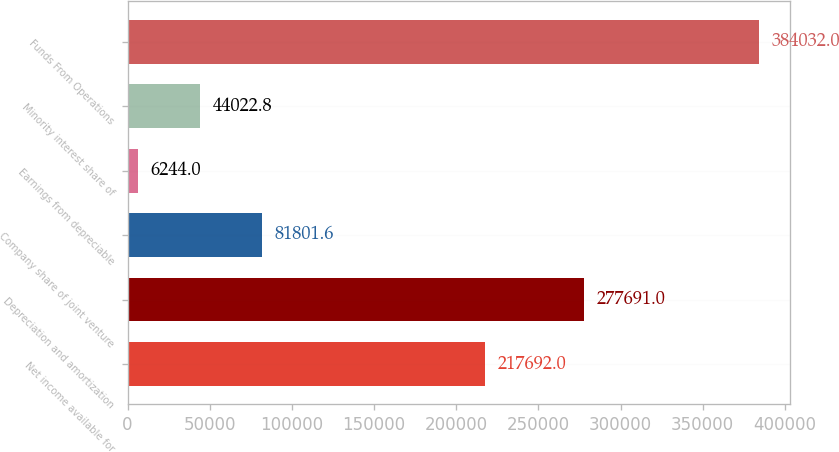<chart> <loc_0><loc_0><loc_500><loc_500><bar_chart><fcel>Net income available for<fcel>Depreciation and amortization<fcel>Company share of joint venture<fcel>Earnings from depreciable<fcel>Minority interest share of<fcel>Funds From Operations<nl><fcel>217692<fcel>277691<fcel>81801.6<fcel>6244<fcel>44022.8<fcel>384032<nl></chart> 